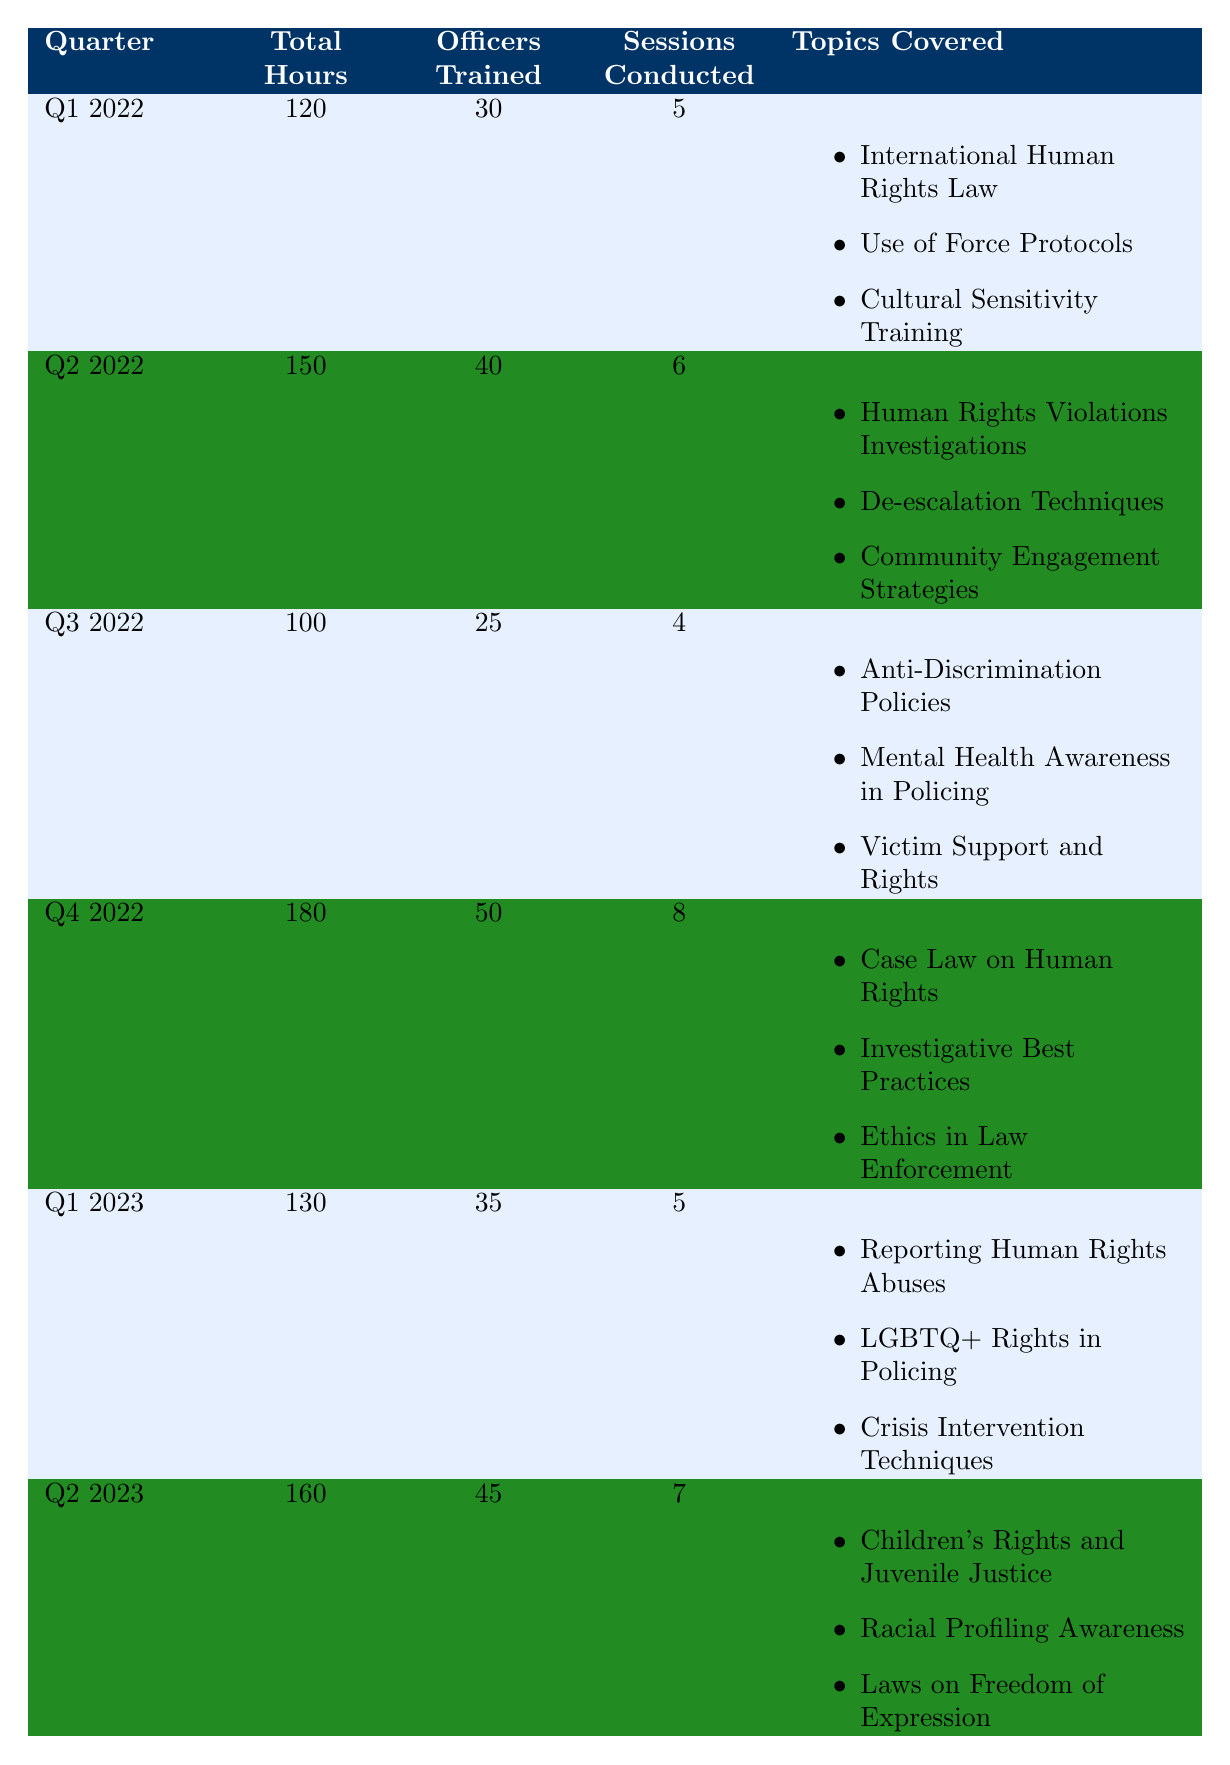What was the total training hours provided in Q4 2022? According to the table, the total training hours for Q4 2022 is explicitly listed as 180 hours.
Answer: 180 How many officers were trained in Q2 2023? The table shows that 45 officers were trained in Q2 2023, as indicated in that row.
Answer: 45 What is the average number of officers trained per session across all quarters? To find the average, we need to calculate the total number of officers trained and divide it by the total number of sessions conducted. The total officers trained is 30 + 40 + 25 + 50 + 35 + 45 = 225. The total sessions conducted is 5 + 6 + 4 + 8 + 5 + 7 = 35. Thus, the average is 225 / 35 = 6.43.
Answer: 6.43 Did the number of sessions conducted increase from Q1 2022 to Q4 2022? In Q1 2022, there were 5 sessions, and in Q4 2022, there were 8 sessions. Since 8 is greater than 5, we can confirm that the number of sessions did indeed increase.
Answer: Yes What was the total training hours provided in Q1 2023 and Q2 2023 combined? We sum the total training hours for Q1 2023 (130) and Q2 2023 (160). Therefore, 130 + 160 = 290 total hours for these two quarters.
Answer: 290 Which quarter had the highest number of officers trained? By examining the number of officers trained for each quarter, we see that Q4 2022 had the highest number with 50 officers trained (as compared to others: Q1 2022 - 30, Q2 2022 - 40, Q3 2022 - 25, Q1 2023 - 35, Q2 2023 - 45).
Answer: Q4 2022 What is the difference in total hours provided between Q4 2022 and Q3 2022? The total hours for Q4 2022 is 180 and for Q3 2022 is 100. The difference is calculated as 180 - 100 = 80.
Answer: 80 Was "Mental Health Awareness in Policing" covered in any of the training sessions? Yes, this topic is listed as one of the topics covered in Q3 2022's training session.
Answer: Yes How many sessions were conducted in total across all quarters? The total number of sessions conducted is the sum from each quarter: 5 + 6 + 4 + 8 + 5 + 7 = 35.
Answer: 35 